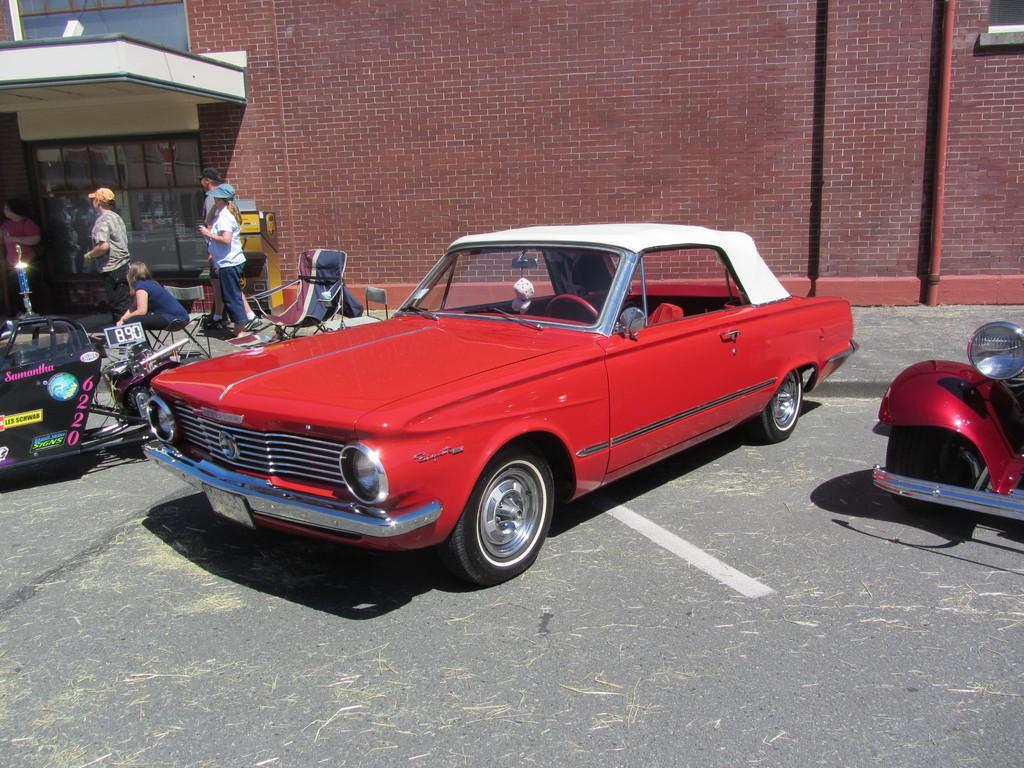In one or two sentences, can you explain what this image depicts? In this picture we can see some vehicles parked on the road and on the road there are chairs, four people are standing and a person is sitting on a chair. Behind the people there is a wall with glass windows and a pipe. 